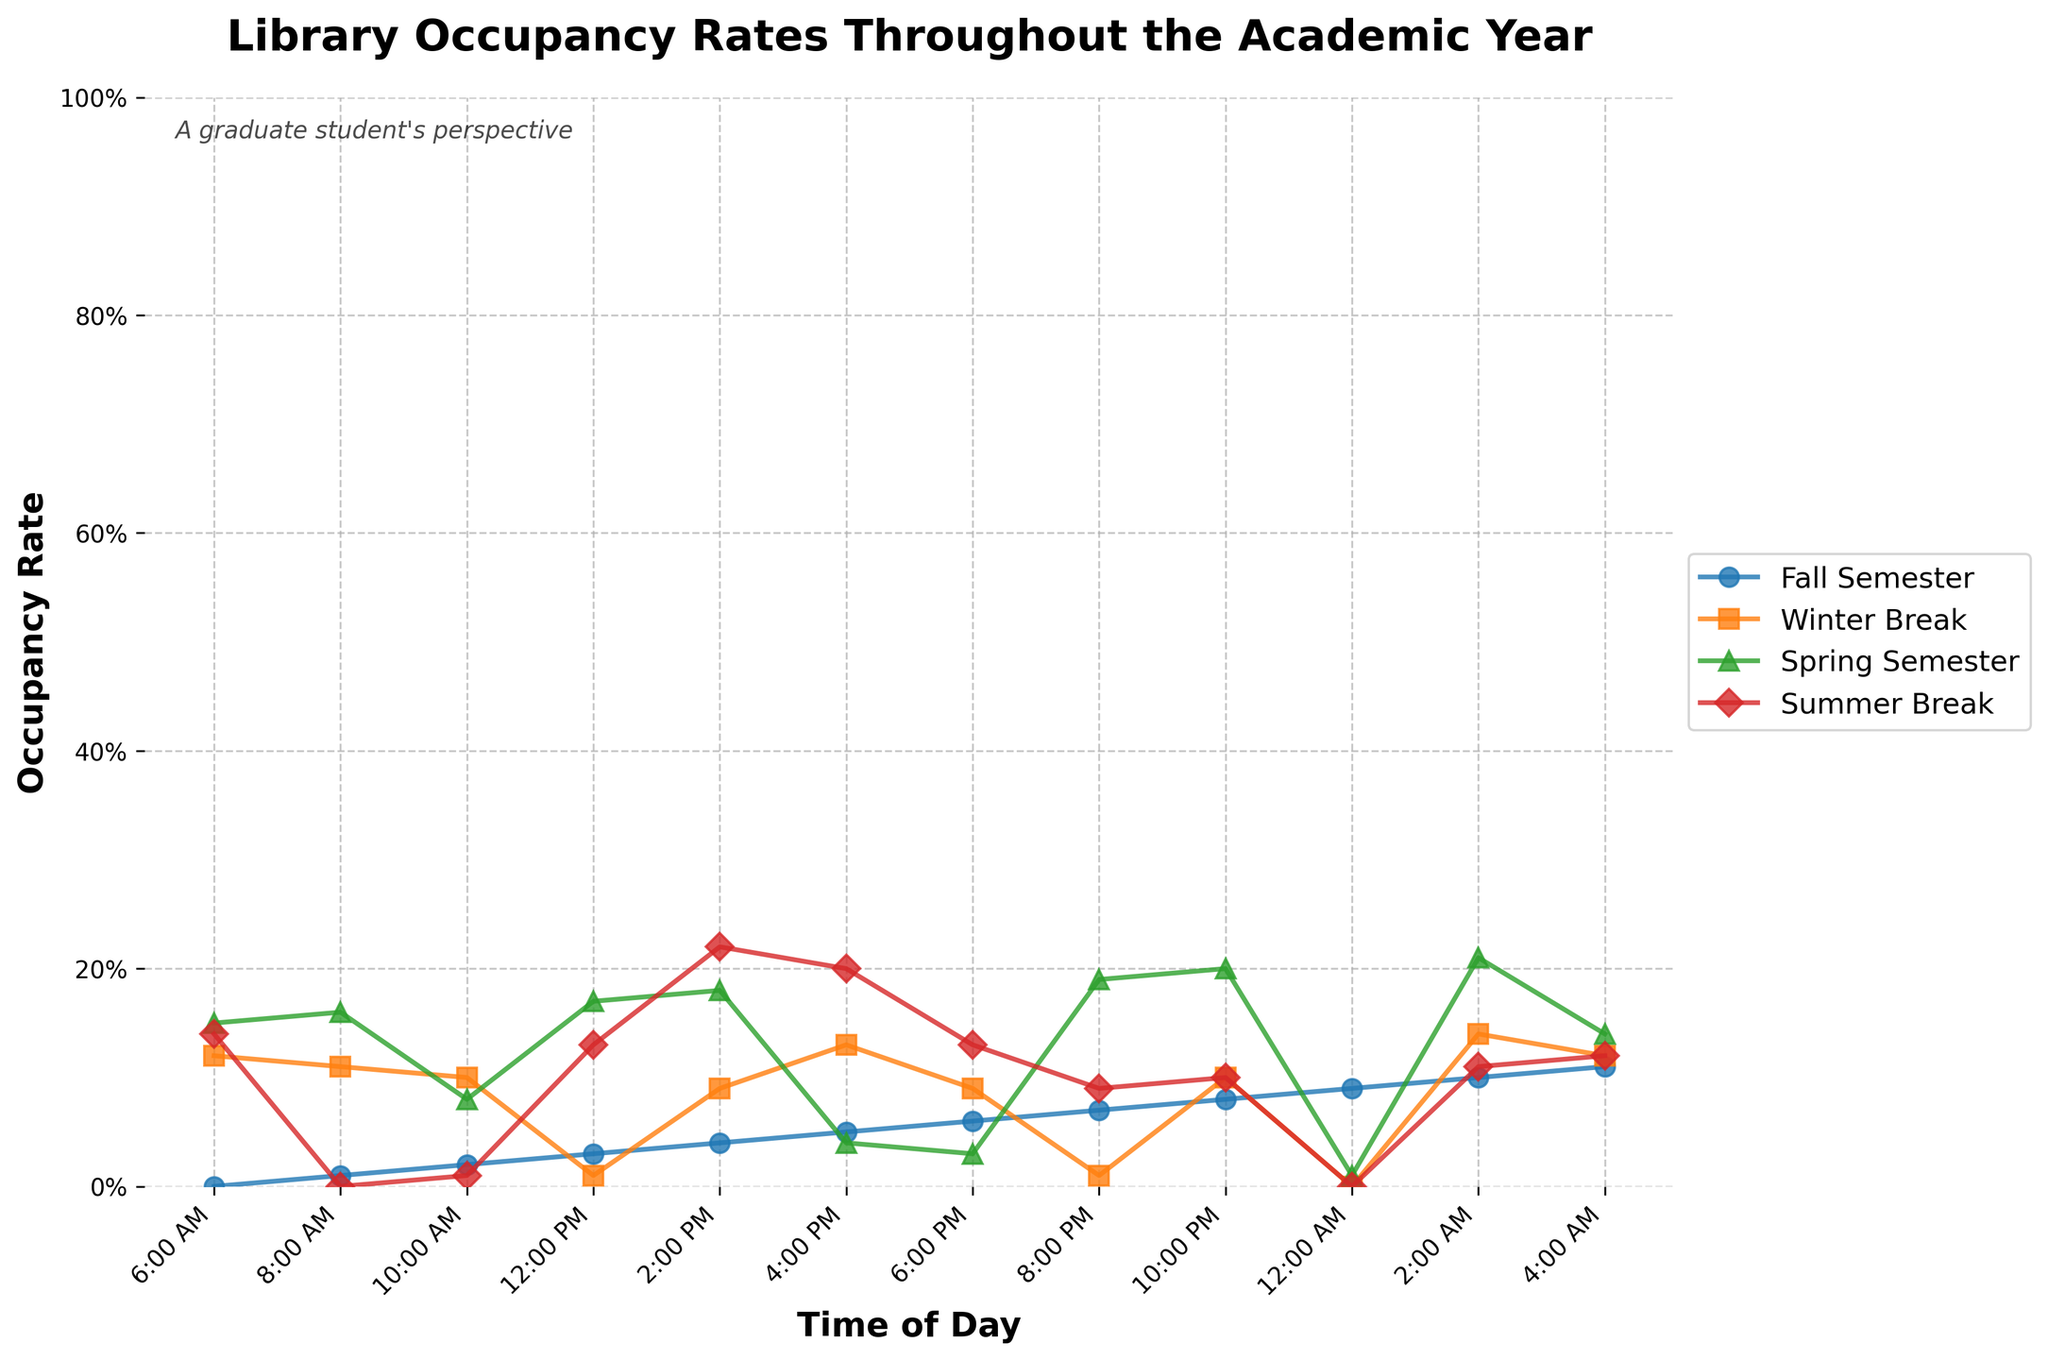What is the occupancy rate at 4:00 PM during the Fall Semester? Locate the Fall Semester line (blue) at the 4:00 PM mark on the x-axis. The y-axis value for this point is 90%.
Answer: 90% How does the occupancy rate at 10:00 AM in the Winter Break compare to the Spring Semester? Locate both Winter Break and Spring Semester lines at the 10:00 AM mark. The Winter Break occupancy rate is 10%, while the Spring Semester rate is 40%.
Answer: Spring Semester is 30% higher than Winter Break Which time of day has the highest occupancy rate during the Summer Break? Look at the Summer Break line (red) and identify the peak. The highest point is at 4:00 PM.
Answer: 4:00 PM What is the average occupancy rate at 6:00 PM across all periods? Identify the 6:00 PM rates for Fall (75%), Winter Break (20%), Spring (70%), and Summer Break (25%). Sum these values and divide by 4: (75% + 20% + 70% + 25%) / 4 = 47.5%
Answer: 47.5% During the Fall Semester, how much does the occupancy rate increase from 8:00 AM to 4:00 PM? Determine the occupancy rates at 8:00 AM (15%) and 4:00 PM (90%) on the Fall Semester line. Subtract the 8:00 AM value from the 4:00 PM value: 90% - 15% = 75%
Answer: 75% At which times of day is the occupancy rate the lowest for the Spring Semester? Identify the minimum values along the Spring Semester line (green). The values are lowest at 4:00 AM (2%).
Answer: 4:00 AM By how much does the occupancy rate drop from 2:00 PM to 10:00 PM during the Summer Break? Locate the occupancy percentages for 2:00 PM (30%) and 10:00 PM (10%) on the Summer Break line (red). Subtract the 10:00 PM value from the 2:00 PM: 30% - 10% = 20%.
Answer: 20% What is the total drop in occupancy rate from 12:00 PM to 2:00 AM during the Fall Semester? Locate the Fall Semester rates at 12:00 PM (70%) and 2:00 AM (10%). The total drop is: 70% - 10% = 60%.
Answer: 60% What is the visual color representation of the Winter Break occupancy line? Observe the color used for the Winter Break line. It is orange.
Answer: orange 